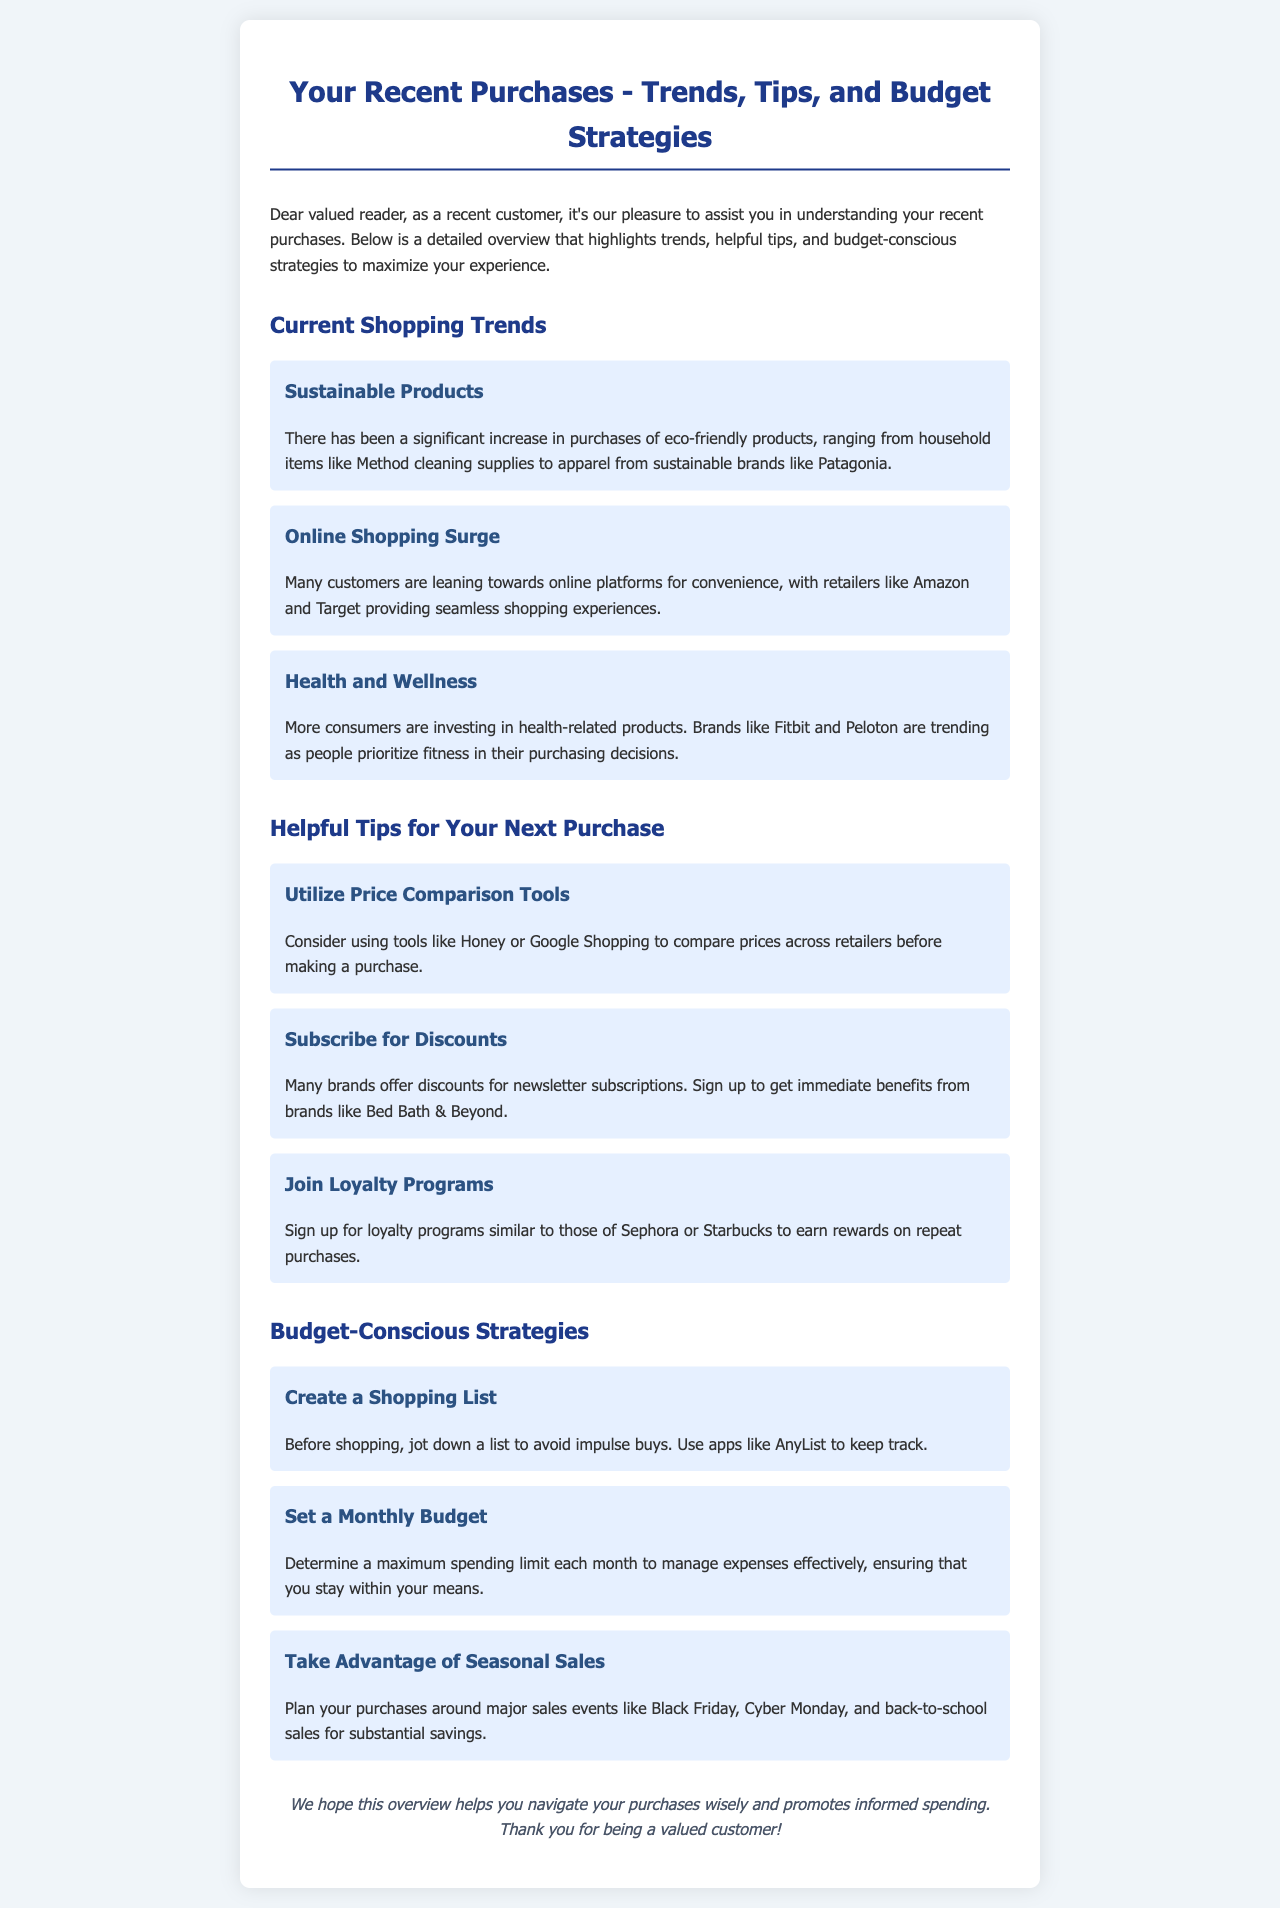What are the current shopping trends? The section titled "Current Shopping Trends" lists significant trends mentioned in the document, such as eco-friendly products, online shopping, and health-related purchases.
Answer: Sustainable Products, Online Shopping Surge, Health and Wellness Which tool can I use to compare prices before purchasing? The document suggests using tools for price comparison, indicating that several options are available to assist customers.
Answer: Honey or Google Shopping What should I do to avoid impulse buys? The document advises a strategy to prevent impulsive spending by recommending a useful tool or method.
Answer: Create a Shopping List Which brands are trending in the health and wellness category? The item under "Health and Wellness" lists specific brands that are currently popular in this sector.
Answer: Fitbit and Peloton How can I benefit from newsletter subscriptions? The document discusses a specific promotion that brands offer which aligns with subscriptions.
Answer: Discounts What is a budget-conscious strategy mentioned in the document? The document provides various strategies aimed at helping customers spend wisely, with one being highlighted specifically for budgeting.
Answer: Set a Monthly Budget What is the suggested action for major sales events? The document emphasizes the importance of timing purchases in accordance with specific sales periods to maximize savings.
Answer: Take Advantage of Seasonal Sales What color theme is predominantly used in the newsletter? The newsletter layout features specific color choices that create a distinct visual theme, as noted in the styles provided.
Answer: Blue and White 